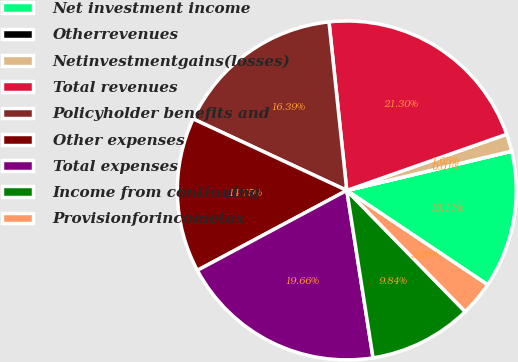Convert chart. <chart><loc_0><loc_0><loc_500><loc_500><pie_chart><fcel>Net investment income<fcel>Otherrevenues<fcel>Netinvestmentgains(losses)<fcel>Total revenues<fcel>Policyholder benefits and<fcel>Other expenses<fcel>Total expenses<fcel>Income from continuing<fcel>Provisionforincometax<nl><fcel>13.11%<fcel>0.01%<fcel>1.65%<fcel>21.3%<fcel>16.39%<fcel>14.75%<fcel>19.66%<fcel>9.84%<fcel>3.29%<nl></chart> 